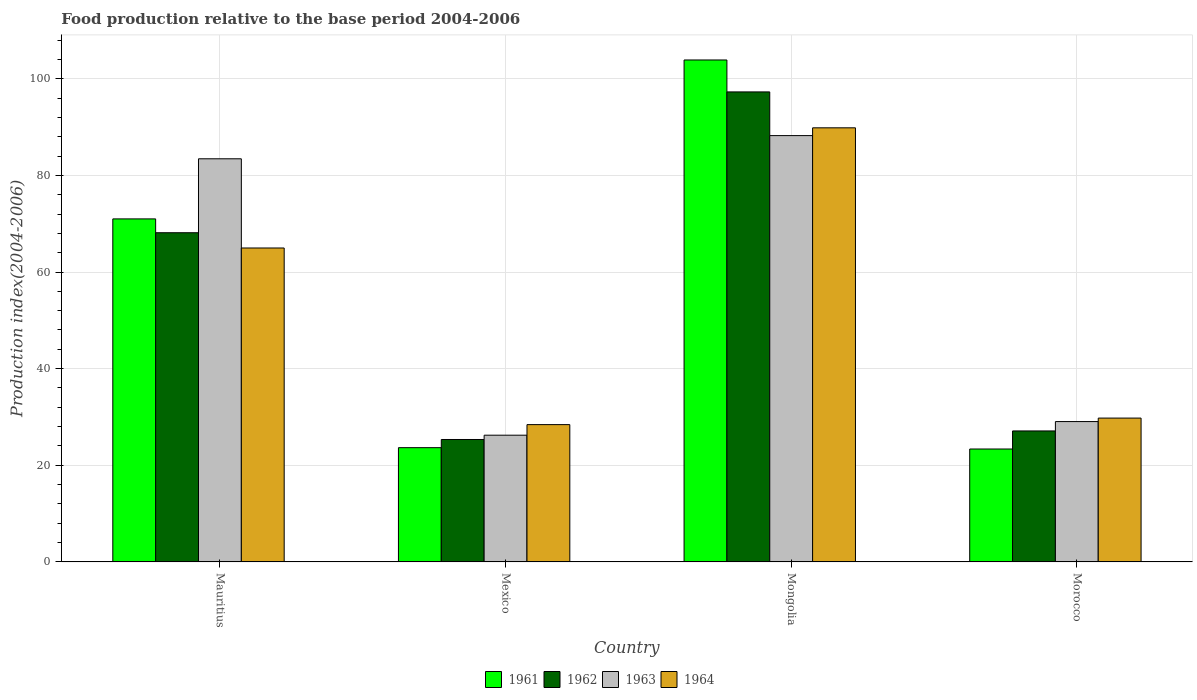Are the number of bars per tick equal to the number of legend labels?
Provide a succinct answer. Yes. Are the number of bars on each tick of the X-axis equal?
Give a very brief answer. Yes. How many bars are there on the 4th tick from the left?
Provide a short and direct response. 4. How many bars are there on the 3rd tick from the right?
Give a very brief answer. 4. What is the label of the 1st group of bars from the left?
Offer a very short reply. Mauritius. In how many cases, is the number of bars for a given country not equal to the number of legend labels?
Your response must be concise. 0. What is the food production index in 1964 in Mexico?
Your answer should be very brief. 28.42. Across all countries, what is the maximum food production index in 1961?
Provide a short and direct response. 103.88. Across all countries, what is the minimum food production index in 1961?
Provide a short and direct response. 23.37. In which country was the food production index in 1964 maximum?
Offer a terse response. Mongolia. What is the total food production index in 1964 in the graph?
Offer a very short reply. 213. What is the difference between the food production index in 1961 in Mexico and that in Morocco?
Provide a succinct answer. 0.28. What is the difference between the food production index in 1964 in Mexico and the food production index in 1962 in Morocco?
Offer a terse response. 1.31. What is the average food production index in 1961 per country?
Provide a short and direct response. 55.47. What is the difference between the food production index of/in 1964 and food production index of/in 1963 in Mexico?
Offer a very short reply. 2.19. In how many countries, is the food production index in 1964 greater than 40?
Make the answer very short. 2. What is the ratio of the food production index in 1962 in Mexico to that in Morocco?
Ensure brevity in your answer.  0.93. Is the food production index in 1961 in Mauritius less than that in Mongolia?
Your answer should be compact. Yes. Is the difference between the food production index in 1964 in Mongolia and Morocco greater than the difference between the food production index in 1963 in Mongolia and Morocco?
Provide a short and direct response. Yes. What is the difference between the highest and the second highest food production index in 1964?
Offer a very short reply. -24.87. What is the difference between the highest and the lowest food production index in 1964?
Provide a short and direct response. 61.42. What does the 4th bar from the left in Morocco represents?
Offer a terse response. 1964. Does the graph contain any zero values?
Offer a very short reply. No. Where does the legend appear in the graph?
Ensure brevity in your answer.  Bottom center. How many legend labels are there?
Keep it short and to the point. 4. What is the title of the graph?
Your answer should be compact. Food production relative to the base period 2004-2006. What is the label or title of the Y-axis?
Your answer should be very brief. Production index(2004-2006). What is the Production index(2004-2006) of 1961 in Mauritius?
Give a very brief answer. 70.99. What is the Production index(2004-2006) of 1962 in Mauritius?
Give a very brief answer. 68.13. What is the Production index(2004-2006) in 1963 in Mauritius?
Give a very brief answer. 83.43. What is the Production index(2004-2006) in 1964 in Mauritius?
Make the answer very short. 64.97. What is the Production index(2004-2006) in 1961 in Mexico?
Provide a short and direct response. 23.65. What is the Production index(2004-2006) of 1962 in Mexico?
Your response must be concise. 25.34. What is the Production index(2004-2006) in 1963 in Mexico?
Provide a succinct answer. 26.23. What is the Production index(2004-2006) of 1964 in Mexico?
Your answer should be very brief. 28.42. What is the Production index(2004-2006) of 1961 in Mongolia?
Offer a terse response. 103.88. What is the Production index(2004-2006) of 1962 in Mongolia?
Your response must be concise. 97.27. What is the Production index(2004-2006) of 1963 in Mongolia?
Ensure brevity in your answer.  88.23. What is the Production index(2004-2006) of 1964 in Mongolia?
Offer a terse response. 89.84. What is the Production index(2004-2006) of 1961 in Morocco?
Your response must be concise. 23.37. What is the Production index(2004-2006) of 1962 in Morocco?
Ensure brevity in your answer.  27.11. What is the Production index(2004-2006) of 1963 in Morocco?
Give a very brief answer. 29.05. What is the Production index(2004-2006) of 1964 in Morocco?
Your response must be concise. 29.77. Across all countries, what is the maximum Production index(2004-2006) of 1961?
Your answer should be compact. 103.88. Across all countries, what is the maximum Production index(2004-2006) of 1962?
Provide a short and direct response. 97.27. Across all countries, what is the maximum Production index(2004-2006) of 1963?
Make the answer very short. 88.23. Across all countries, what is the maximum Production index(2004-2006) of 1964?
Your answer should be compact. 89.84. Across all countries, what is the minimum Production index(2004-2006) in 1961?
Give a very brief answer. 23.37. Across all countries, what is the minimum Production index(2004-2006) of 1962?
Your answer should be very brief. 25.34. Across all countries, what is the minimum Production index(2004-2006) in 1963?
Your answer should be compact. 26.23. Across all countries, what is the minimum Production index(2004-2006) of 1964?
Offer a terse response. 28.42. What is the total Production index(2004-2006) of 1961 in the graph?
Offer a very short reply. 221.89. What is the total Production index(2004-2006) of 1962 in the graph?
Give a very brief answer. 217.85. What is the total Production index(2004-2006) of 1963 in the graph?
Make the answer very short. 226.94. What is the total Production index(2004-2006) in 1964 in the graph?
Provide a succinct answer. 213. What is the difference between the Production index(2004-2006) of 1961 in Mauritius and that in Mexico?
Make the answer very short. 47.34. What is the difference between the Production index(2004-2006) of 1962 in Mauritius and that in Mexico?
Your answer should be compact. 42.79. What is the difference between the Production index(2004-2006) of 1963 in Mauritius and that in Mexico?
Make the answer very short. 57.2. What is the difference between the Production index(2004-2006) of 1964 in Mauritius and that in Mexico?
Your response must be concise. 36.55. What is the difference between the Production index(2004-2006) in 1961 in Mauritius and that in Mongolia?
Make the answer very short. -32.89. What is the difference between the Production index(2004-2006) of 1962 in Mauritius and that in Mongolia?
Your answer should be compact. -29.14. What is the difference between the Production index(2004-2006) in 1964 in Mauritius and that in Mongolia?
Give a very brief answer. -24.87. What is the difference between the Production index(2004-2006) of 1961 in Mauritius and that in Morocco?
Provide a short and direct response. 47.62. What is the difference between the Production index(2004-2006) in 1962 in Mauritius and that in Morocco?
Your answer should be very brief. 41.02. What is the difference between the Production index(2004-2006) in 1963 in Mauritius and that in Morocco?
Your response must be concise. 54.38. What is the difference between the Production index(2004-2006) in 1964 in Mauritius and that in Morocco?
Provide a succinct answer. 35.2. What is the difference between the Production index(2004-2006) of 1961 in Mexico and that in Mongolia?
Your response must be concise. -80.23. What is the difference between the Production index(2004-2006) in 1962 in Mexico and that in Mongolia?
Make the answer very short. -71.93. What is the difference between the Production index(2004-2006) in 1963 in Mexico and that in Mongolia?
Ensure brevity in your answer.  -62. What is the difference between the Production index(2004-2006) of 1964 in Mexico and that in Mongolia?
Offer a terse response. -61.42. What is the difference between the Production index(2004-2006) in 1961 in Mexico and that in Morocco?
Keep it short and to the point. 0.28. What is the difference between the Production index(2004-2006) in 1962 in Mexico and that in Morocco?
Your answer should be compact. -1.77. What is the difference between the Production index(2004-2006) in 1963 in Mexico and that in Morocco?
Your response must be concise. -2.82. What is the difference between the Production index(2004-2006) in 1964 in Mexico and that in Morocco?
Offer a terse response. -1.35. What is the difference between the Production index(2004-2006) of 1961 in Mongolia and that in Morocco?
Keep it short and to the point. 80.51. What is the difference between the Production index(2004-2006) in 1962 in Mongolia and that in Morocco?
Make the answer very short. 70.16. What is the difference between the Production index(2004-2006) in 1963 in Mongolia and that in Morocco?
Give a very brief answer. 59.18. What is the difference between the Production index(2004-2006) in 1964 in Mongolia and that in Morocco?
Keep it short and to the point. 60.07. What is the difference between the Production index(2004-2006) in 1961 in Mauritius and the Production index(2004-2006) in 1962 in Mexico?
Provide a succinct answer. 45.65. What is the difference between the Production index(2004-2006) of 1961 in Mauritius and the Production index(2004-2006) of 1963 in Mexico?
Make the answer very short. 44.76. What is the difference between the Production index(2004-2006) in 1961 in Mauritius and the Production index(2004-2006) in 1964 in Mexico?
Provide a short and direct response. 42.57. What is the difference between the Production index(2004-2006) of 1962 in Mauritius and the Production index(2004-2006) of 1963 in Mexico?
Offer a terse response. 41.9. What is the difference between the Production index(2004-2006) in 1962 in Mauritius and the Production index(2004-2006) in 1964 in Mexico?
Give a very brief answer. 39.71. What is the difference between the Production index(2004-2006) of 1963 in Mauritius and the Production index(2004-2006) of 1964 in Mexico?
Your answer should be compact. 55.01. What is the difference between the Production index(2004-2006) of 1961 in Mauritius and the Production index(2004-2006) of 1962 in Mongolia?
Your answer should be very brief. -26.28. What is the difference between the Production index(2004-2006) in 1961 in Mauritius and the Production index(2004-2006) in 1963 in Mongolia?
Offer a terse response. -17.24. What is the difference between the Production index(2004-2006) in 1961 in Mauritius and the Production index(2004-2006) in 1964 in Mongolia?
Provide a succinct answer. -18.85. What is the difference between the Production index(2004-2006) in 1962 in Mauritius and the Production index(2004-2006) in 1963 in Mongolia?
Give a very brief answer. -20.1. What is the difference between the Production index(2004-2006) of 1962 in Mauritius and the Production index(2004-2006) of 1964 in Mongolia?
Offer a terse response. -21.71. What is the difference between the Production index(2004-2006) of 1963 in Mauritius and the Production index(2004-2006) of 1964 in Mongolia?
Your answer should be compact. -6.41. What is the difference between the Production index(2004-2006) in 1961 in Mauritius and the Production index(2004-2006) in 1962 in Morocco?
Make the answer very short. 43.88. What is the difference between the Production index(2004-2006) of 1961 in Mauritius and the Production index(2004-2006) of 1963 in Morocco?
Your answer should be very brief. 41.94. What is the difference between the Production index(2004-2006) in 1961 in Mauritius and the Production index(2004-2006) in 1964 in Morocco?
Your response must be concise. 41.22. What is the difference between the Production index(2004-2006) of 1962 in Mauritius and the Production index(2004-2006) of 1963 in Morocco?
Offer a terse response. 39.08. What is the difference between the Production index(2004-2006) in 1962 in Mauritius and the Production index(2004-2006) in 1964 in Morocco?
Provide a succinct answer. 38.36. What is the difference between the Production index(2004-2006) in 1963 in Mauritius and the Production index(2004-2006) in 1964 in Morocco?
Keep it short and to the point. 53.66. What is the difference between the Production index(2004-2006) of 1961 in Mexico and the Production index(2004-2006) of 1962 in Mongolia?
Provide a short and direct response. -73.62. What is the difference between the Production index(2004-2006) in 1961 in Mexico and the Production index(2004-2006) in 1963 in Mongolia?
Provide a succinct answer. -64.58. What is the difference between the Production index(2004-2006) in 1961 in Mexico and the Production index(2004-2006) in 1964 in Mongolia?
Give a very brief answer. -66.19. What is the difference between the Production index(2004-2006) of 1962 in Mexico and the Production index(2004-2006) of 1963 in Mongolia?
Ensure brevity in your answer.  -62.89. What is the difference between the Production index(2004-2006) in 1962 in Mexico and the Production index(2004-2006) in 1964 in Mongolia?
Your response must be concise. -64.5. What is the difference between the Production index(2004-2006) in 1963 in Mexico and the Production index(2004-2006) in 1964 in Mongolia?
Offer a terse response. -63.61. What is the difference between the Production index(2004-2006) in 1961 in Mexico and the Production index(2004-2006) in 1962 in Morocco?
Ensure brevity in your answer.  -3.46. What is the difference between the Production index(2004-2006) in 1961 in Mexico and the Production index(2004-2006) in 1964 in Morocco?
Your answer should be very brief. -6.12. What is the difference between the Production index(2004-2006) of 1962 in Mexico and the Production index(2004-2006) of 1963 in Morocco?
Give a very brief answer. -3.71. What is the difference between the Production index(2004-2006) in 1962 in Mexico and the Production index(2004-2006) in 1964 in Morocco?
Your answer should be compact. -4.43. What is the difference between the Production index(2004-2006) of 1963 in Mexico and the Production index(2004-2006) of 1964 in Morocco?
Your answer should be very brief. -3.54. What is the difference between the Production index(2004-2006) in 1961 in Mongolia and the Production index(2004-2006) in 1962 in Morocco?
Ensure brevity in your answer.  76.77. What is the difference between the Production index(2004-2006) in 1961 in Mongolia and the Production index(2004-2006) in 1963 in Morocco?
Keep it short and to the point. 74.83. What is the difference between the Production index(2004-2006) of 1961 in Mongolia and the Production index(2004-2006) of 1964 in Morocco?
Your response must be concise. 74.11. What is the difference between the Production index(2004-2006) of 1962 in Mongolia and the Production index(2004-2006) of 1963 in Morocco?
Your answer should be compact. 68.22. What is the difference between the Production index(2004-2006) of 1962 in Mongolia and the Production index(2004-2006) of 1964 in Morocco?
Your answer should be compact. 67.5. What is the difference between the Production index(2004-2006) of 1963 in Mongolia and the Production index(2004-2006) of 1964 in Morocco?
Provide a succinct answer. 58.46. What is the average Production index(2004-2006) in 1961 per country?
Provide a short and direct response. 55.47. What is the average Production index(2004-2006) in 1962 per country?
Provide a succinct answer. 54.46. What is the average Production index(2004-2006) of 1963 per country?
Give a very brief answer. 56.73. What is the average Production index(2004-2006) of 1964 per country?
Offer a very short reply. 53.25. What is the difference between the Production index(2004-2006) of 1961 and Production index(2004-2006) of 1962 in Mauritius?
Give a very brief answer. 2.86. What is the difference between the Production index(2004-2006) of 1961 and Production index(2004-2006) of 1963 in Mauritius?
Keep it short and to the point. -12.44. What is the difference between the Production index(2004-2006) of 1961 and Production index(2004-2006) of 1964 in Mauritius?
Keep it short and to the point. 6.02. What is the difference between the Production index(2004-2006) of 1962 and Production index(2004-2006) of 1963 in Mauritius?
Make the answer very short. -15.3. What is the difference between the Production index(2004-2006) of 1962 and Production index(2004-2006) of 1964 in Mauritius?
Give a very brief answer. 3.16. What is the difference between the Production index(2004-2006) in 1963 and Production index(2004-2006) in 1964 in Mauritius?
Give a very brief answer. 18.46. What is the difference between the Production index(2004-2006) of 1961 and Production index(2004-2006) of 1962 in Mexico?
Provide a succinct answer. -1.69. What is the difference between the Production index(2004-2006) in 1961 and Production index(2004-2006) in 1963 in Mexico?
Offer a very short reply. -2.58. What is the difference between the Production index(2004-2006) of 1961 and Production index(2004-2006) of 1964 in Mexico?
Your response must be concise. -4.77. What is the difference between the Production index(2004-2006) of 1962 and Production index(2004-2006) of 1963 in Mexico?
Your answer should be compact. -0.89. What is the difference between the Production index(2004-2006) of 1962 and Production index(2004-2006) of 1964 in Mexico?
Keep it short and to the point. -3.08. What is the difference between the Production index(2004-2006) in 1963 and Production index(2004-2006) in 1964 in Mexico?
Provide a succinct answer. -2.19. What is the difference between the Production index(2004-2006) of 1961 and Production index(2004-2006) of 1962 in Mongolia?
Keep it short and to the point. 6.61. What is the difference between the Production index(2004-2006) in 1961 and Production index(2004-2006) in 1963 in Mongolia?
Provide a short and direct response. 15.65. What is the difference between the Production index(2004-2006) in 1961 and Production index(2004-2006) in 1964 in Mongolia?
Give a very brief answer. 14.04. What is the difference between the Production index(2004-2006) in 1962 and Production index(2004-2006) in 1963 in Mongolia?
Offer a terse response. 9.04. What is the difference between the Production index(2004-2006) of 1962 and Production index(2004-2006) of 1964 in Mongolia?
Give a very brief answer. 7.43. What is the difference between the Production index(2004-2006) of 1963 and Production index(2004-2006) of 1964 in Mongolia?
Make the answer very short. -1.61. What is the difference between the Production index(2004-2006) of 1961 and Production index(2004-2006) of 1962 in Morocco?
Make the answer very short. -3.74. What is the difference between the Production index(2004-2006) in 1961 and Production index(2004-2006) in 1963 in Morocco?
Provide a short and direct response. -5.68. What is the difference between the Production index(2004-2006) in 1962 and Production index(2004-2006) in 1963 in Morocco?
Your response must be concise. -1.94. What is the difference between the Production index(2004-2006) in 1962 and Production index(2004-2006) in 1964 in Morocco?
Keep it short and to the point. -2.66. What is the difference between the Production index(2004-2006) of 1963 and Production index(2004-2006) of 1964 in Morocco?
Offer a very short reply. -0.72. What is the ratio of the Production index(2004-2006) in 1961 in Mauritius to that in Mexico?
Give a very brief answer. 3. What is the ratio of the Production index(2004-2006) of 1962 in Mauritius to that in Mexico?
Provide a succinct answer. 2.69. What is the ratio of the Production index(2004-2006) of 1963 in Mauritius to that in Mexico?
Keep it short and to the point. 3.18. What is the ratio of the Production index(2004-2006) of 1964 in Mauritius to that in Mexico?
Offer a terse response. 2.29. What is the ratio of the Production index(2004-2006) of 1961 in Mauritius to that in Mongolia?
Your response must be concise. 0.68. What is the ratio of the Production index(2004-2006) in 1962 in Mauritius to that in Mongolia?
Provide a succinct answer. 0.7. What is the ratio of the Production index(2004-2006) in 1963 in Mauritius to that in Mongolia?
Your answer should be compact. 0.95. What is the ratio of the Production index(2004-2006) of 1964 in Mauritius to that in Mongolia?
Your answer should be compact. 0.72. What is the ratio of the Production index(2004-2006) of 1961 in Mauritius to that in Morocco?
Provide a succinct answer. 3.04. What is the ratio of the Production index(2004-2006) of 1962 in Mauritius to that in Morocco?
Provide a short and direct response. 2.51. What is the ratio of the Production index(2004-2006) of 1963 in Mauritius to that in Morocco?
Give a very brief answer. 2.87. What is the ratio of the Production index(2004-2006) of 1964 in Mauritius to that in Morocco?
Your answer should be very brief. 2.18. What is the ratio of the Production index(2004-2006) in 1961 in Mexico to that in Mongolia?
Make the answer very short. 0.23. What is the ratio of the Production index(2004-2006) in 1962 in Mexico to that in Mongolia?
Provide a succinct answer. 0.26. What is the ratio of the Production index(2004-2006) in 1963 in Mexico to that in Mongolia?
Your answer should be compact. 0.3. What is the ratio of the Production index(2004-2006) in 1964 in Mexico to that in Mongolia?
Your response must be concise. 0.32. What is the ratio of the Production index(2004-2006) in 1962 in Mexico to that in Morocco?
Provide a short and direct response. 0.93. What is the ratio of the Production index(2004-2006) in 1963 in Mexico to that in Morocco?
Your response must be concise. 0.9. What is the ratio of the Production index(2004-2006) in 1964 in Mexico to that in Morocco?
Ensure brevity in your answer.  0.95. What is the ratio of the Production index(2004-2006) in 1961 in Mongolia to that in Morocco?
Your answer should be compact. 4.45. What is the ratio of the Production index(2004-2006) of 1962 in Mongolia to that in Morocco?
Your answer should be compact. 3.59. What is the ratio of the Production index(2004-2006) in 1963 in Mongolia to that in Morocco?
Keep it short and to the point. 3.04. What is the ratio of the Production index(2004-2006) in 1964 in Mongolia to that in Morocco?
Give a very brief answer. 3.02. What is the difference between the highest and the second highest Production index(2004-2006) in 1961?
Your answer should be very brief. 32.89. What is the difference between the highest and the second highest Production index(2004-2006) of 1962?
Make the answer very short. 29.14. What is the difference between the highest and the second highest Production index(2004-2006) in 1963?
Your answer should be compact. 4.8. What is the difference between the highest and the second highest Production index(2004-2006) of 1964?
Your response must be concise. 24.87. What is the difference between the highest and the lowest Production index(2004-2006) of 1961?
Make the answer very short. 80.51. What is the difference between the highest and the lowest Production index(2004-2006) in 1962?
Offer a very short reply. 71.93. What is the difference between the highest and the lowest Production index(2004-2006) of 1963?
Offer a terse response. 62. What is the difference between the highest and the lowest Production index(2004-2006) in 1964?
Provide a short and direct response. 61.42. 